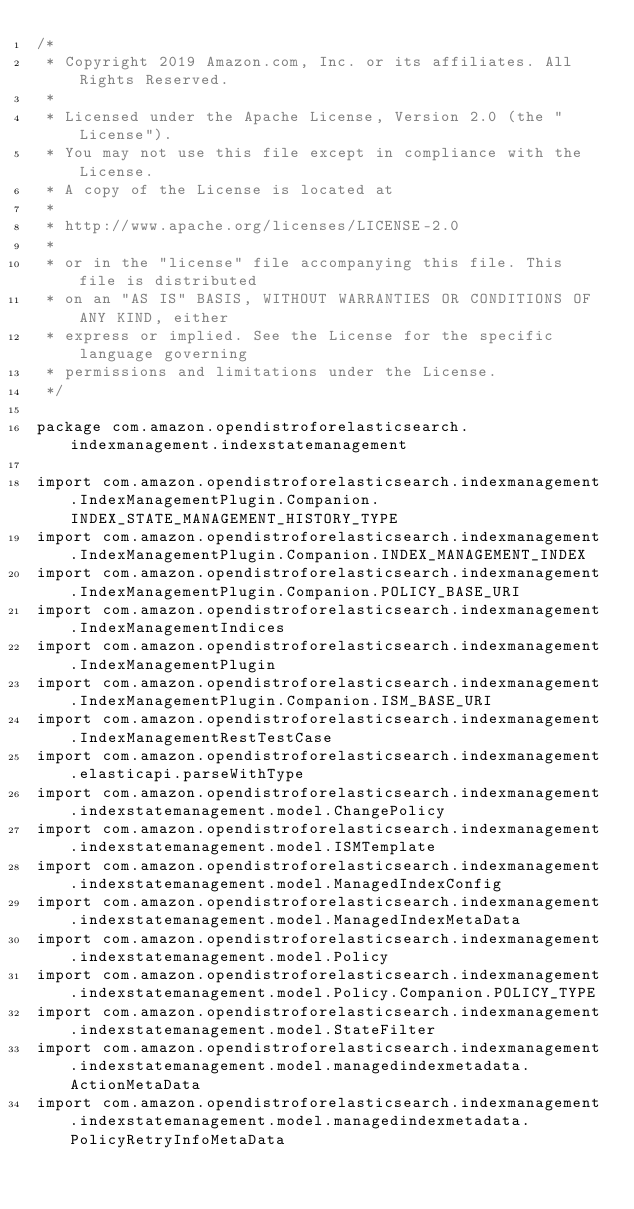<code> <loc_0><loc_0><loc_500><loc_500><_Kotlin_>/*
 * Copyright 2019 Amazon.com, Inc. or its affiliates. All Rights Reserved.
 *
 * Licensed under the Apache License, Version 2.0 (the "License").
 * You may not use this file except in compliance with the License.
 * A copy of the License is located at
 *
 * http://www.apache.org/licenses/LICENSE-2.0
 *
 * or in the "license" file accompanying this file. This file is distributed
 * on an "AS IS" BASIS, WITHOUT WARRANTIES OR CONDITIONS OF ANY KIND, either
 * express or implied. See the License for the specific language governing
 * permissions and limitations under the License.
 */

package com.amazon.opendistroforelasticsearch.indexmanagement.indexstatemanagement

import com.amazon.opendistroforelasticsearch.indexmanagement.IndexManagementPlugin.Companion.INDEX_STATE_MANAGEMENT_HISTORY_TYPE
import com.amazon.opendistroforelasticsearch.indexmanagement.IndexManagementPlugin.Companion.INDEX_MANAGEMENT_INDEX
import com.amazon.opendistroforelasticsearch.indexmanagement.IndexManagementPlugin.Companion.POLICY_BASE_URI
import com.amazon.opendistroforelasticsearch.indexmanagement.IndexManagementIndices
import com.amazon.opendistroforelasticsearch.indexmanagement.IndexManagementPlugin
import com.amazon.opendistroforelasticsearch.indexmanagement.IndexManagementPlugin.Companion.ISM_BASE_URI
import com.amazon.opendistroforelasticsearch.indexmanagement.IndexManagementRestTestCase
import com.amazon.opendistroforelasticsearch.indexmanagement.elasticapi.parseWithType
import com.amazon.opendistroforelasticsearch.indexmanagement.indexstatemanagement.model.ChangePolicy
import com.amazon.opendistroforelasticsearch.indexmanagement.indexstatemanagement.model.ISMTemplate
import com.amazon.opendistroforelasticsearch.indexmanagement.indexstatemanagement.model.ManagedIndexConfig
import com.amazon.opendistroforelasticsearch.indexmanagement.indexstatemanagement.model.ManagedIndexMetaData
import com.amazon.opendistroforelasticsearch.indexmanagement.indexstatemanagement.model.Policy
import com.amazon.opendistroforelasticsearch.indexmanagement.indexstatemanagement.model.Policy.Companion.POLICY_TYPE
import com.amazon.opendistroforelasticsearch.indexmanagement.indexstatemanagement.model.StateFilter
import com.amazon.opendistroforelasticsearch.indexmanagement.indexstatemanagement.model.managedindexmetadata.ActionMetaData
import com.amazon.opendistroforelasticsearch.indexmanagement.indexstatemanagement.model.managedindexmetadata.PolicyRetryInfoMetaData</code> 